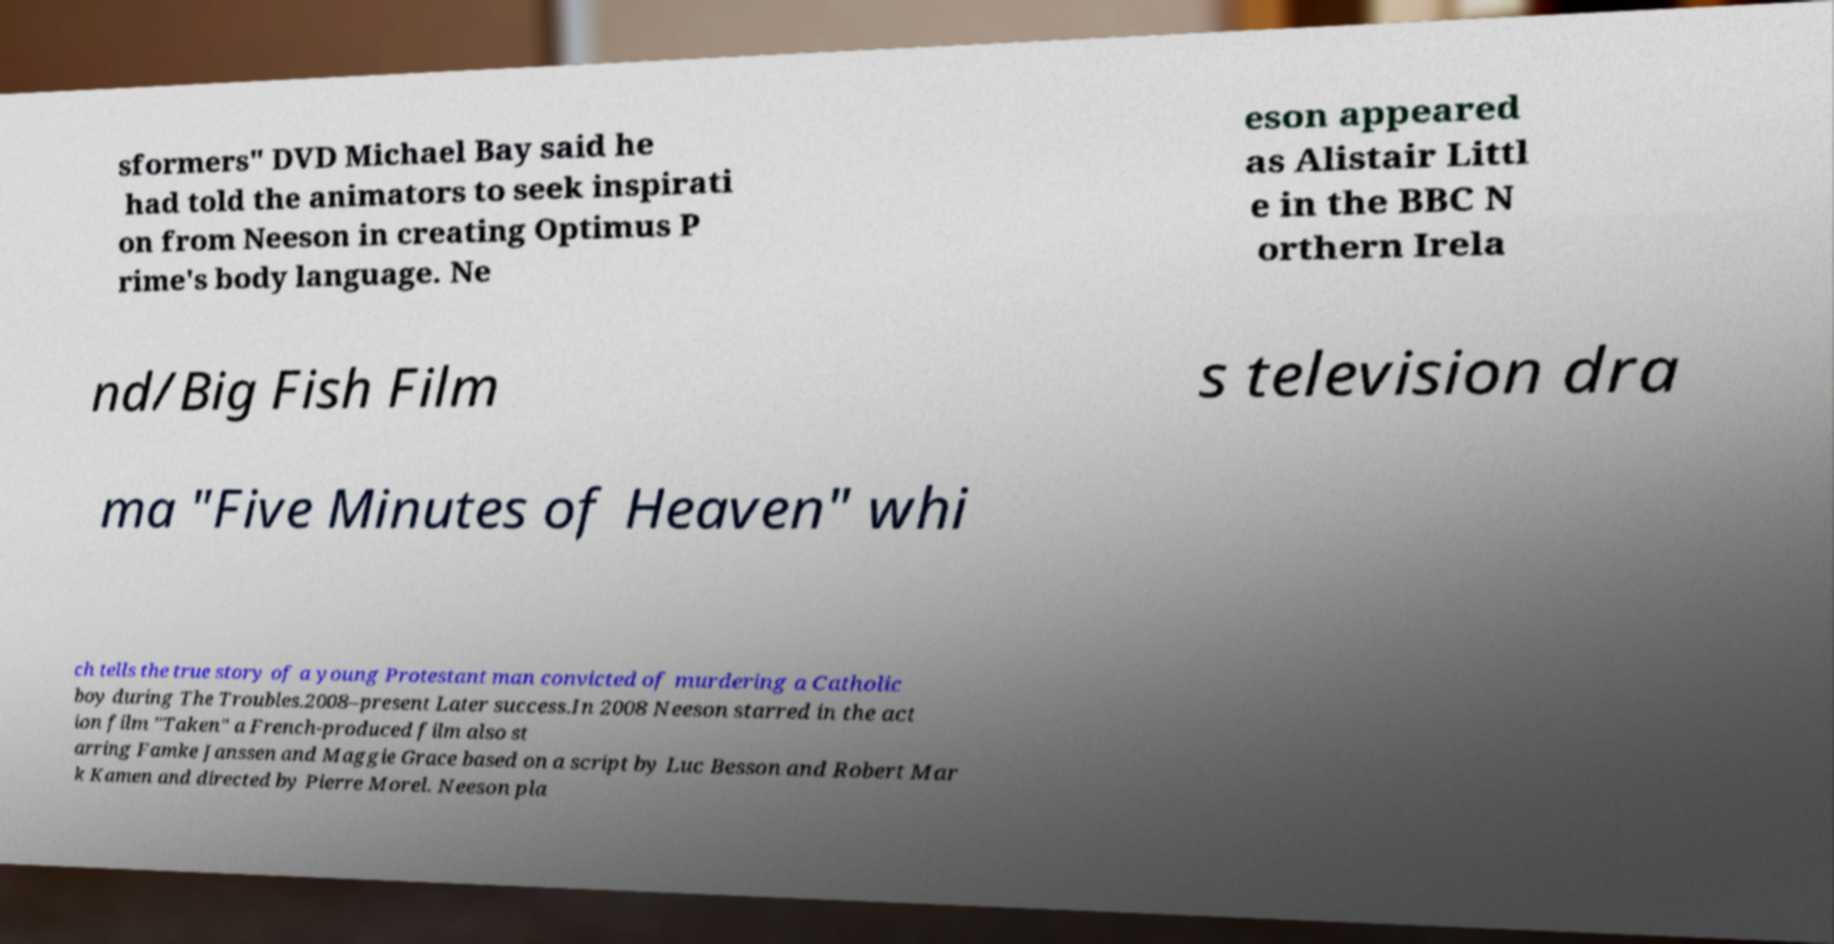I need the written content from this picture converted into text. Can you do that? sformers" DVD Michael Bay said he had told the animators to seek inspirati on from Neeson in creating Optimus P rime's body language. Ne eson appeared as Alistair Littl e in the BBC N orthern Irela nd/Big Fish Film s television dra ma "Five Minutes of Heaven" whi ch tells the true story of a young Protestant man convicted of murdering a Catholic boy during The Troubles.2008–present Later success.In 2008 Neeson starred in the act ion film "Taken" a French-produced film also st arring Famke Janssen and Maggie Grace based on a script by Luc Besson and Robert Mar k Kamen and directed by Pierre Morel. Neeson pla 